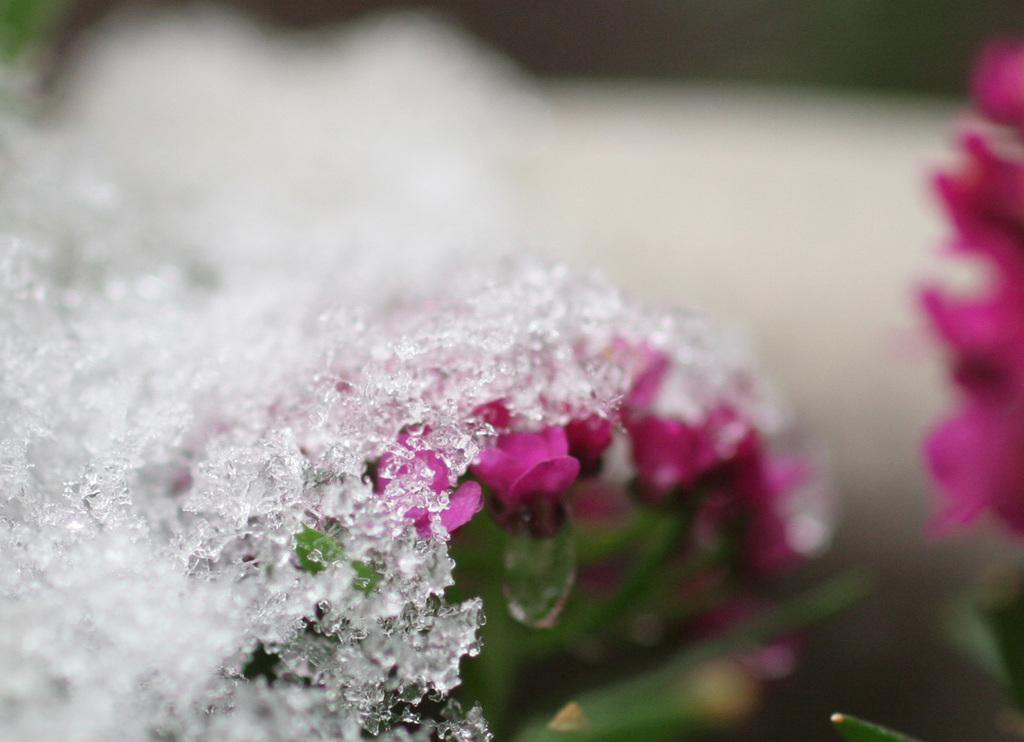What is the main subject in the front of the image? There is a white object in the front of the image. What can be seen in the center of the image? There are flowers in the center of the image. How would you describe the background of the image? The background of the image is blurry. What type of polish is being applied to the mother's nails in the image? There is no mother or nail polish present in the image. What kind of structure is visible in the background of the image? There is no structure visible in the image; the background is blurry. 